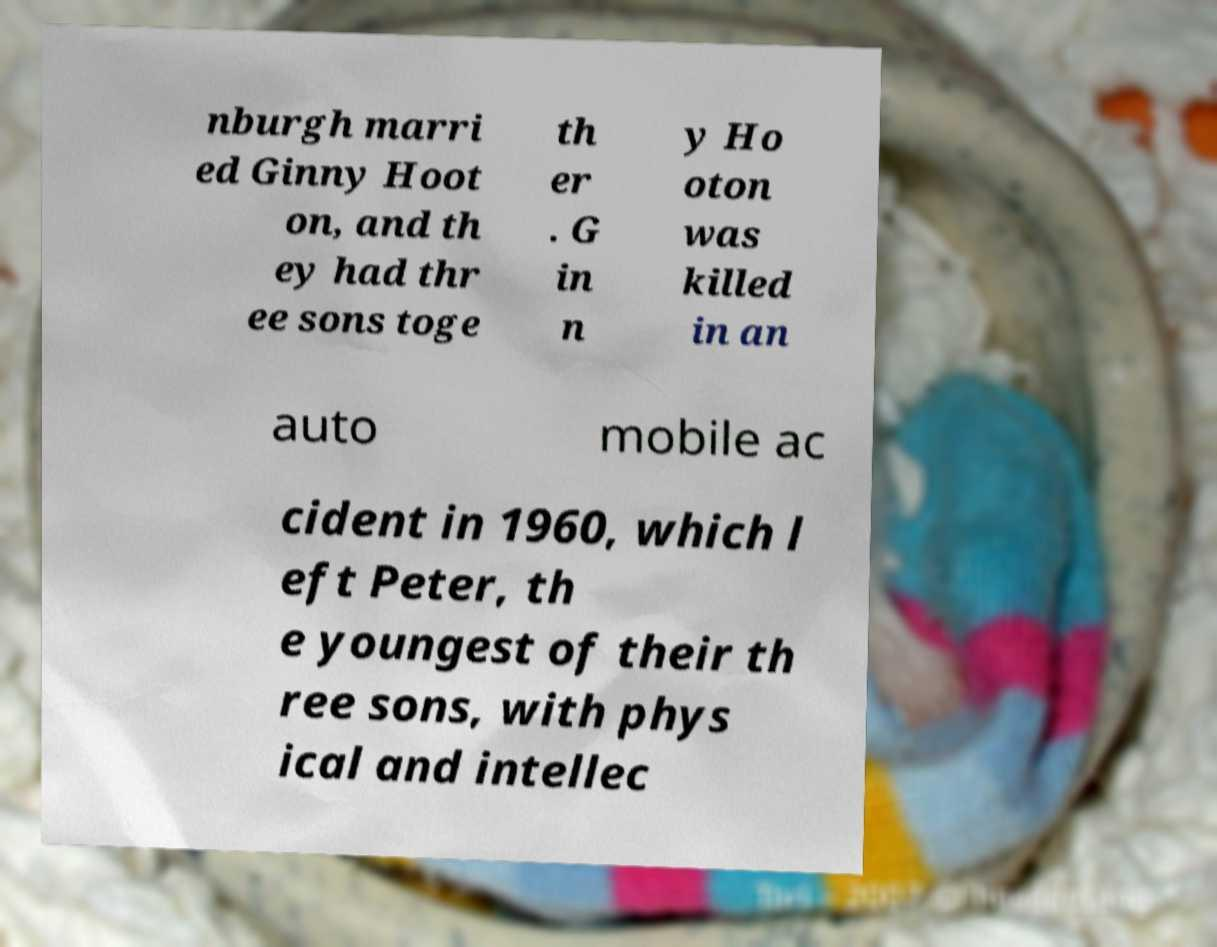Can you accurately transcribe the text from the provided image for me? nburgh marri ed Ginny Hoot on, and th ey had thr ee sons toge th er . G in n y Ho oton was killed in an auto mobile ac cident in 1960, which l eft Peter, th e youngest of their th ree sons, with phys ical and intellec 